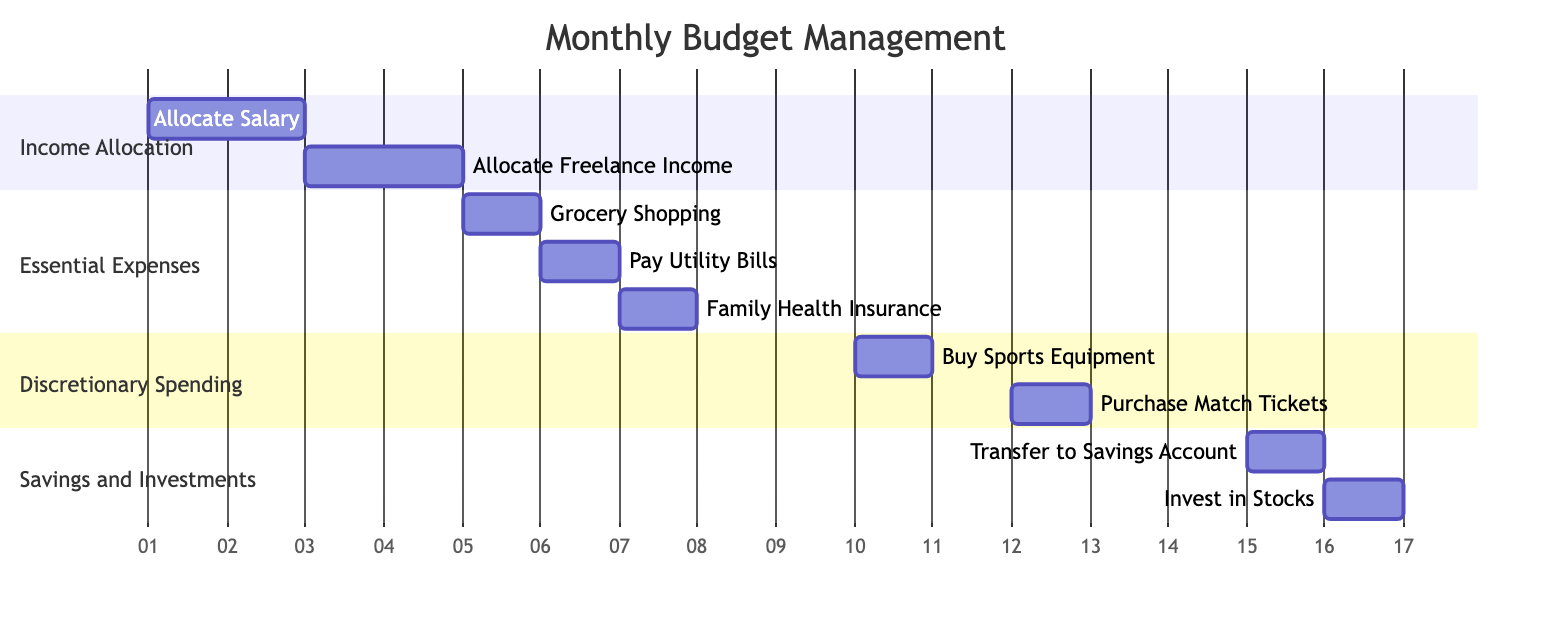What is the task that starts on October 1? The diagram shows that "Allocate Salary" starts on October 1 in the "Income Allocation" section.
Answer: Allocate Salary How many tasks are in the "Essential Expenses" section? There are three tasks listed under the "Essential Expenses" section: Grocery Shopping, Pay Utility Bills, and Family Health Insurance.
Answer: 3 What is the date for transferring to the savings account? The task "Transfer to Savings Account" is scheduled for October 15, as indicated in the "Savings and Investments" section.
Answer: October 15 Which task follows "Buy Sports Equipment"? The next task listed after "Buy Sports Equipment" is "Purchase Match Tickets", occurring on October 12 in the "Discretionary Spending" section.
Answer: Purchase Match Tickets What is the last task of the month according to the diagram? The last task shown in the diagram is "Invest in Stocks", which is scheduled for October 16 in the "Savings and Investments" section.
Answer: Invest in Stocks How many days does the "Income Allocation" section span? The "Income Allocation" section includes two tasks that span from October 1 to October 4, meaning it covers a total of 4 days.
Answer: 4 days Which section includes the task "Family Health Insurance"? The task "Family Health Insurance" is included in the "Essential Expenses" section as shown in the Gantt chart.
Answer: Essential Expenses On what date does the discretionary spending activities start? The discretionary spending activities start with "Buy Sports Equipment" on October 10 in the "Discretionary Spending" section.
Answer: October 10 What is the total number of activities planned in the diagram? Adding the activities from all sections, there are a total of eight planned tasks in the diagram.
Answer: 8 